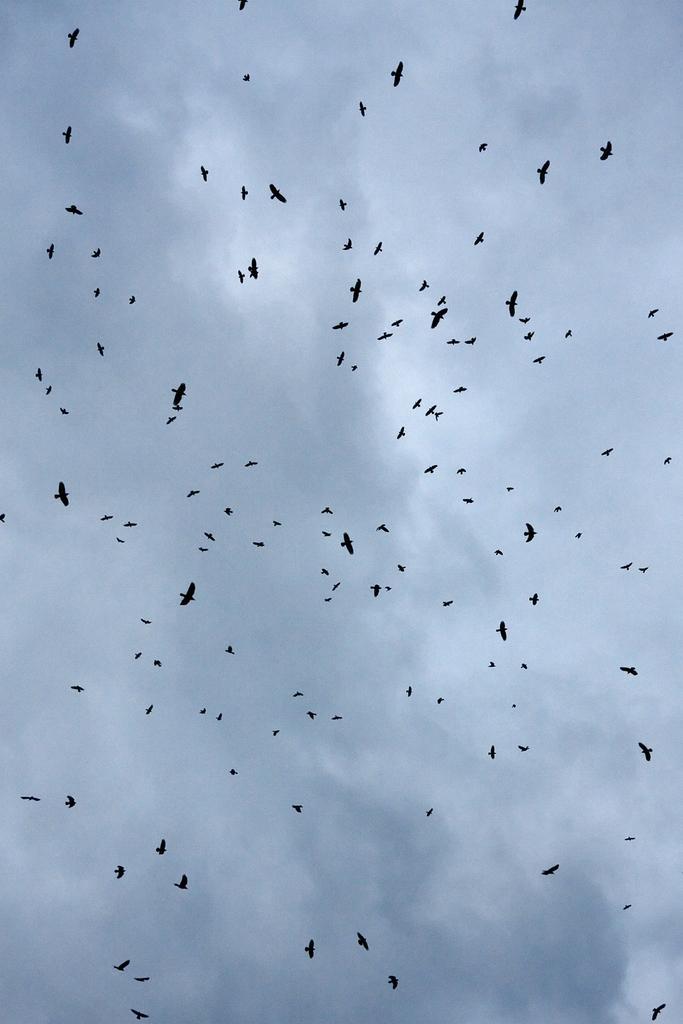Can you describe this image briefly? In this image I can see many birds flying in the air. In the background, I can see the sky and it is cloudy. 